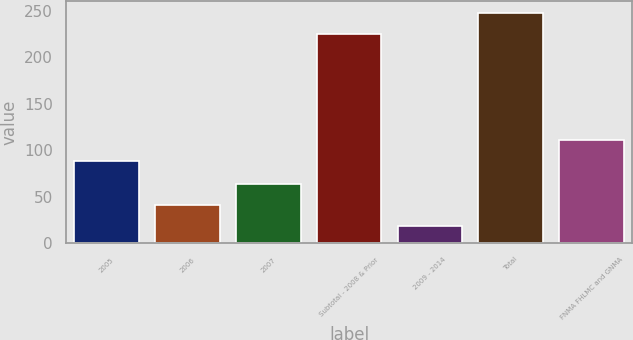Convert chart to OTSL. <chart><loc_0><loc_0><loc_500><loc_500><bar_chart><fcel>2005<fcel>2006<fcel>2007<fcel>Subtotal - 2008 & Prior<fcel>2009 - 2014<fcel>Total<fcel>FNMA FHLMC and GNMA<nl><fcel>88<fcel>41.5<fcel>64<fcel>225<fcel>19<fcel>247.5<fcel>110.5<nl></chart> 